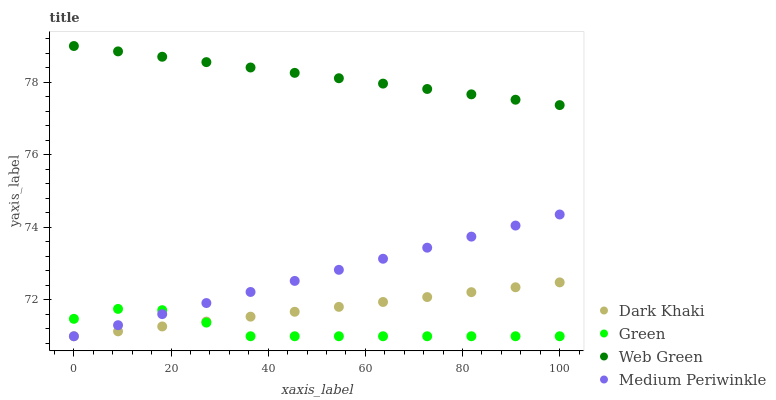Does Green have the minimum area under the curve?
Answer yes or no. Yes. Does Web Green have the maximum area under the curve?
Answer yes or no. Yes. Does Medium Periwinkle have the minimum area under the curve?
Answer yes or no. No. Does Medium Periwinkle have the maximum area under the curve?
Answer yes or no. No. Is Medium Periwinkle the smoothest?
Answer yes or no. Yes. Is Green the roughest?
Answer yes or no. Yes. Is Green the smoothest?
Answer yes or no. No. Is Medium Periwinkle the roughest?
Answer yes or no. No. Does Dark Khaki have the lowest value?
Answer yes or no. Yes. Does Web Green have the lowest value?
Answer yes or no. No. Does Web Green have the highest value?
Answer yes or no. Yes. Does Medium Periwinkle have the highest value?
Answer yes or no. No. Is Dark Khaki less than Web Green?
Answer yes or no. Yes. Is Web Green greater than Dark Khaki?
Answer yes or no. Yes. Does Green intersect Medium Periwinkle?
Answer yes or no. Yes. Is Green less than Medium Periwinkle?
Answer yes or no. No. Is Green greater than Medium Periwinkle?
Answer yes or no. No. Does Dark Khaki intersect Web Green?
Answer yes or no. No. 